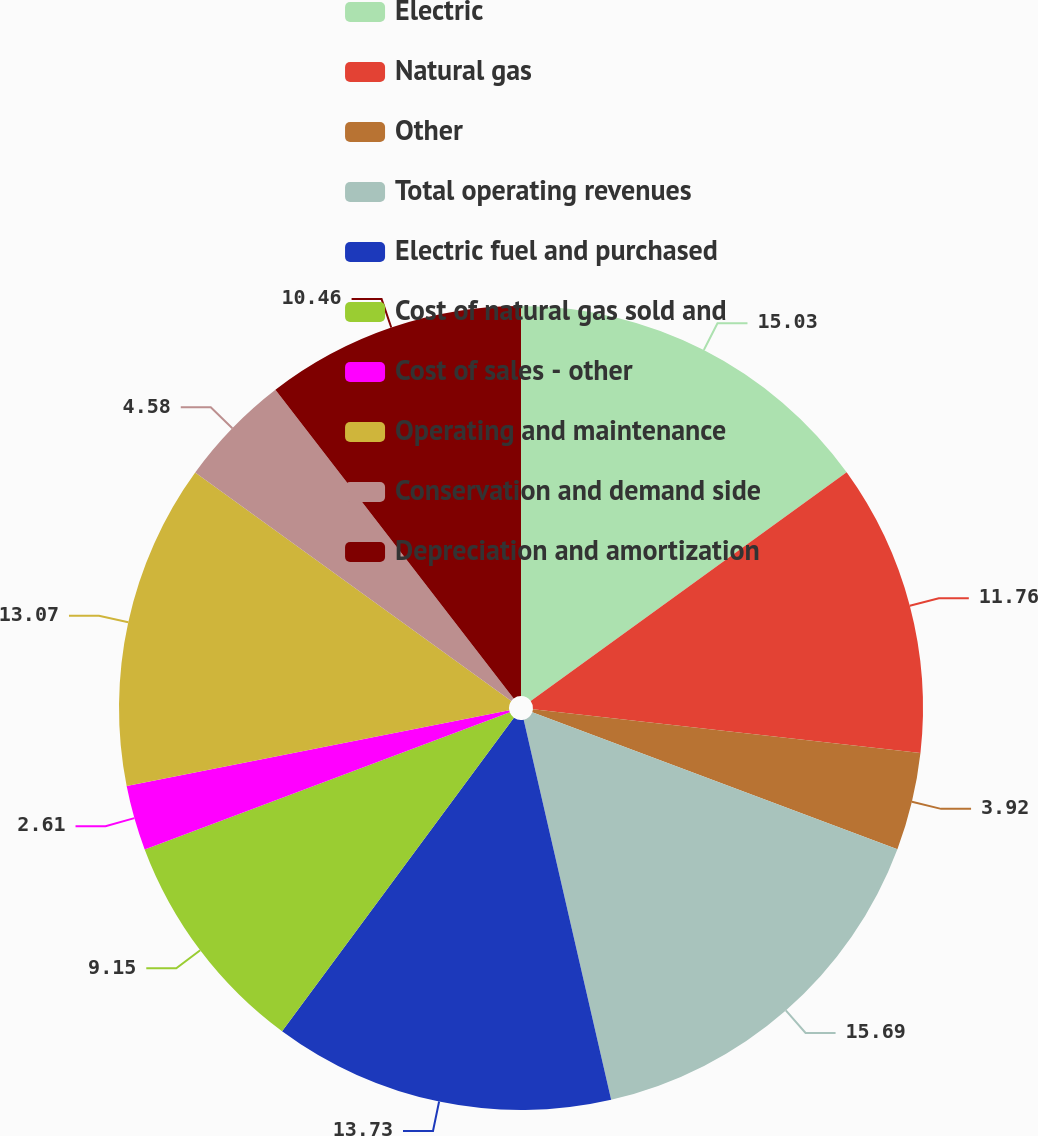Convert chart to OTSL. <chart><loc_0><loc_0><loc_500><loc_500><pie_chart><fcel>Electric<fcel>Natural gas<fcel>Other<fcel>Total operating revenues<fcel>Electric fuel and purchased<fcel>Cost of natural gas sold and<fcel>Cost of sales - other<fcel>Operating and maintenance<fcel>Conservation and demand side<fcel>Depreciation and amortization<nl><fcel>15.03%<fcel>11.76%<fcel>3.92%<fcel>15.69%<fcel>13.73%<fcel>9.15%<fcel>2.61%<fcel>13.07%<fcel>4.58%<fcel>10.46%<nl></chart> 